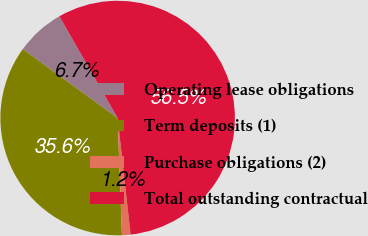<chart> <loc_0><loc_0><loc_500><loc_500><pie_chart><fcel>Operating lease obligations<fcel>Term deposits (1)<fcel>Purchase obligations (2)<fcel>Total outstanding contractual<nl><fcel>6.72%<fcel>35.58%<fcel>1.18%<fcel>56.52%<nl></chart> 